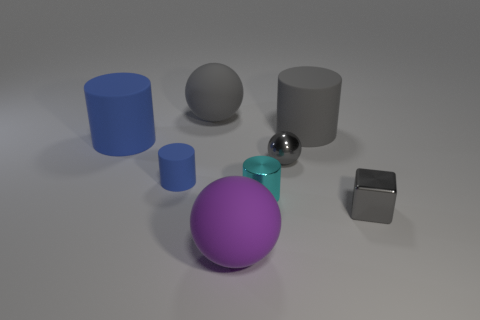Add 2 tiny green metal things. How many objects exist? 10 Subtract all balls. How many objects are left? 5 Add 3 big blue rubber cylinders. How many big blue rubber cylinders exist? 4 Subtract 0 purple cylinders. How many objects are left? 8 Subtract all big blue matte objects. Subtract all big blue cylinders. How many objects are left? 6 Add 5 metal balls. How many metal balls are left? 6 